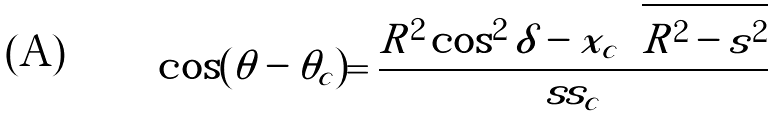<formula> <loc_0><loc_0><loc_500><loc_500>\cos ( \theta - \theta _ { c } ) = \frac { R ^ { 2 } \cos ^ { 2 } \delta - x _ { c } \sqrt { R ^ { 2 } - s ^ { 2 } } } { s s _ { c } }</formula> 